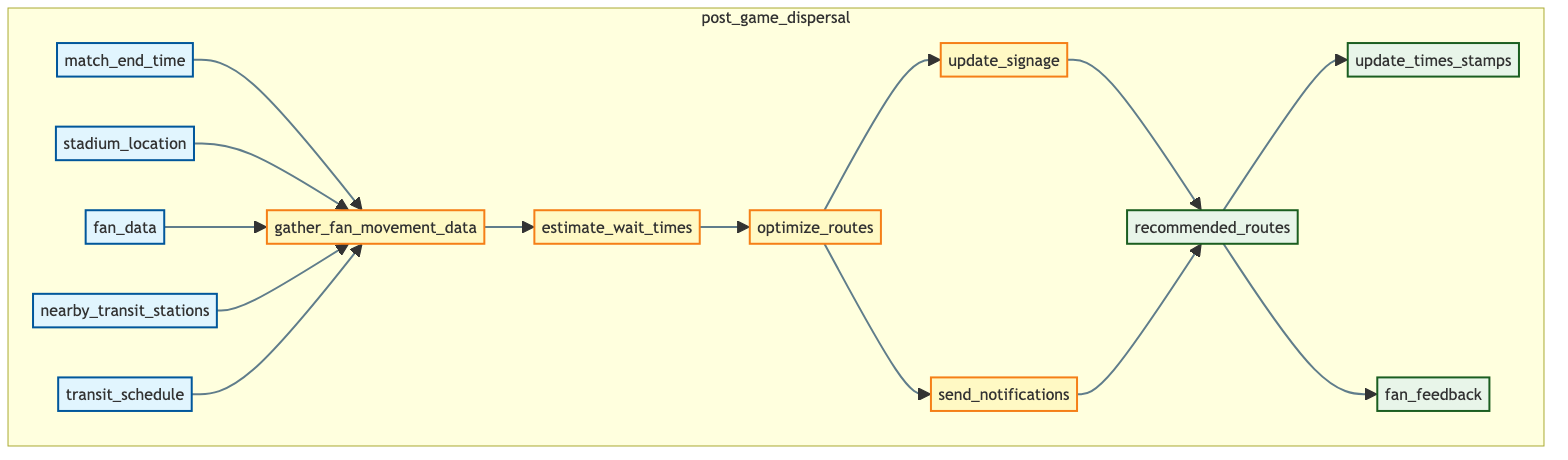What are the inputs of the function? The inputs of the function are shown in the first layer of the diagram: match_end_time, stadium_location, fan_data, nearby_transit_stations, and transit_schedule.
Answer: match_end_time, stadium_location, fan_data, nearby_transit_stations, transit_schedule How many processes are involved in the function? There are five processes described in the diagram: gather_fan_movement_data, estimate_wait_times, optimize_routes, update_signage, and send_notifications.
Answer: five Which process follows the 'gather_fan_movement_data' step? The process that follows 'gather_fan_movement_data' is 'estimate_wait_times', as indicated by the directed flow from F to G in the diagram.
Answer: estimate_wait_times What outputs are generated after 'send_notifications'? The outputs generated after 'send_notifications' include 'recommended_routes', 'update_times_stamps', and 'fan_feedback'. Both 'update_times_stamps' and 'fan_feedback' are connected to 'recommended_routes', indicating they are outputs from the preceding processes.
Answer: recommended_routes, update_times_stamps, fan_feedback What is the relationship between 'optimize_routes' and 'update_signage'? The relationship is that 'update_signage' follows 'optimize_routes' in the process flow, indicating that the routes are optimized before the signage is updated to guide fans to transit stations.
Answer: optimize_routes leads to update_signage Which input affects 'estimate_wait_times'? The input that affects 'estimate_wait_times' is 'gather_fan_movement_data', as it uses the real-time data collected to perform the wait time estimations.
Answer: gather_fan_movement_data How do the processes transition to outputs? The processes transition to outputs through recommendation and real-time updates. The output 'recommended_routes' is produced after the processes 'update_signage' and 'send_notifications', leading to the final outputs of the function.
Answer: through recommendation and real-time updates What type of data does 'fan_feedback' represent in the output? 'Fan_feedback' represents qualitative data about the fans' experiences and thoughts regarding the transit guidance provided after the match.
Answer: qualitative data What is the primary purpose of the 'post_game_dispersal' function? The primary purpose is to efficiently guide fans to public transit after a match, utilizing real-time data and optimized routing.
Answer: guiding fans to public transit 